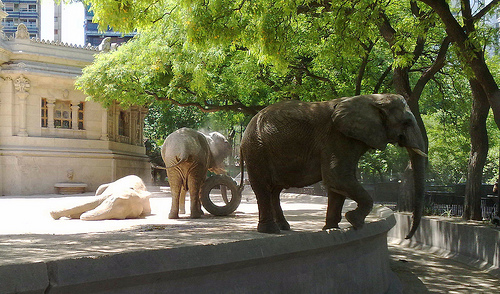Can you describe the setting of the picture? The picture depicts a serene outdoor setting within what could be a zoo or animal sanctuary, showcasing a paved exhibit area bordered by a low wall, with lush green trees providing shade, and classical-style buildings visible in the background. Are there any people in the image? No, there are no people visible in the image. It's a quiet moment with just the elephants present. 